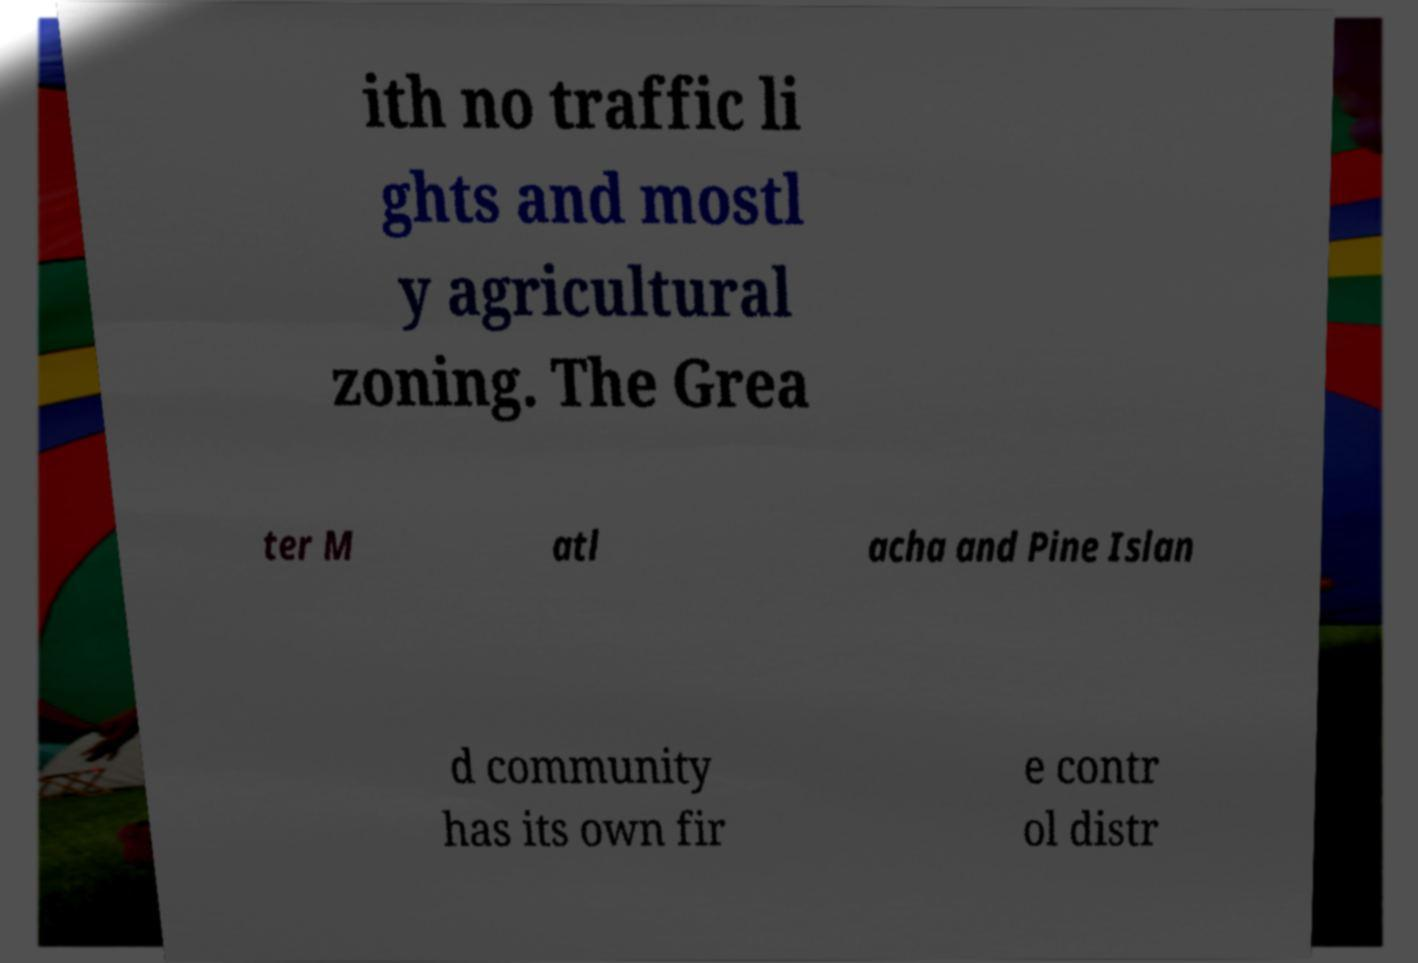Please identify and transcribe the text found in this image. ith no traffic li ghts and mostl y agricultural zoning. The Grea ter M atl acha and Pine Islan d community has its own fir e contr ol distr 